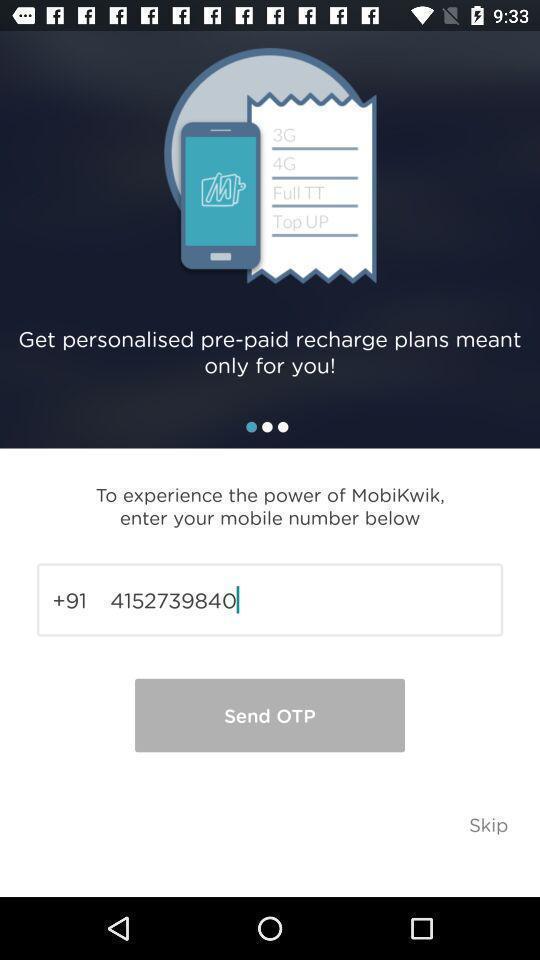Describe the visual elements of this screenshot. Page displaying to enter personal information. 